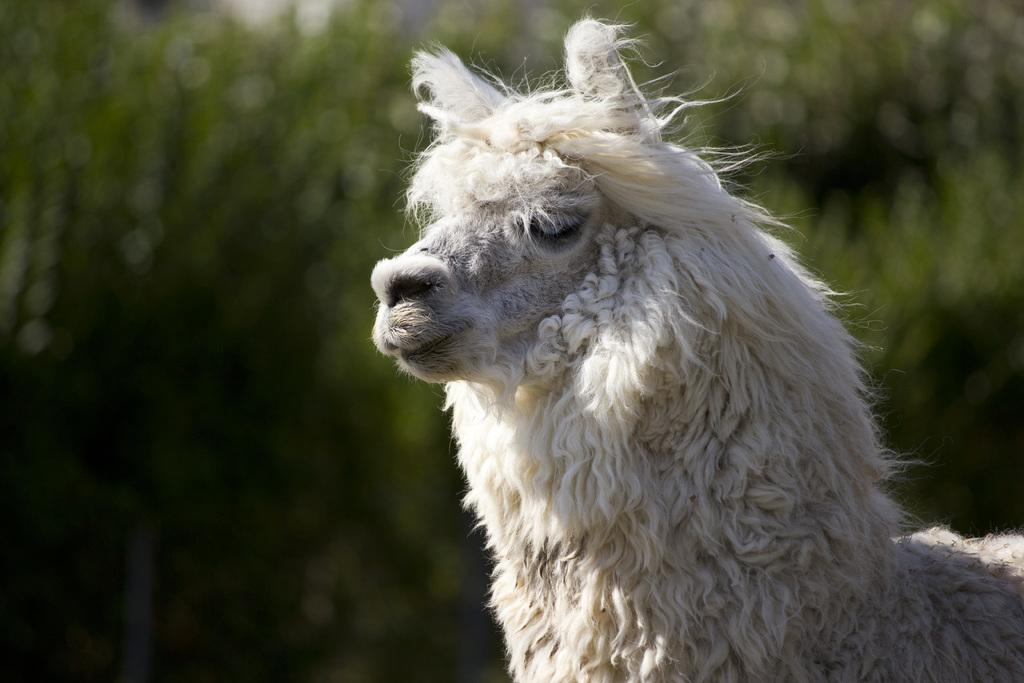What type of subject is present in the image? There is an animal in the image. Can you describe the background of the image? The background of the image is blurred. What type of art is displayed on the animal's jeans in the image? There is no mention of art or jeans in the image; it only features an animal with a blurred background. 